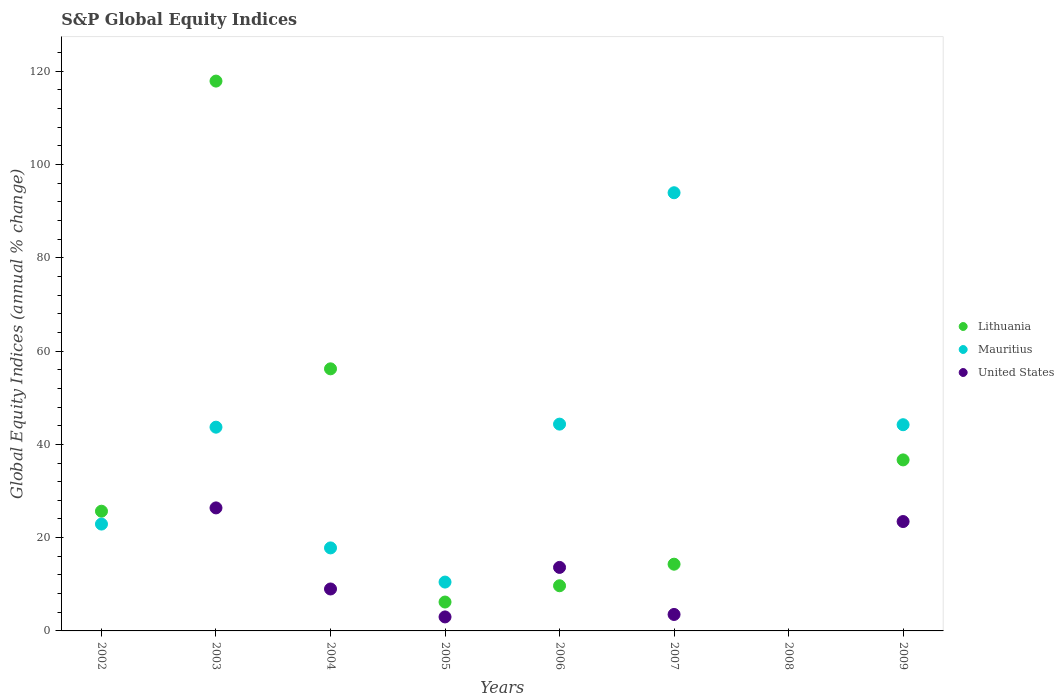Across all years, what is the maximum global equity indices in United States?
Keep it short and to the point. 26.38. In which year was the global equity indices in Mauritius maximum?
Ensure brevity in your answer.  2007. What is the total global equity indices in Mauritius in the graph?
Provide a short and direct response. 277.39. What is the difference between the global equity indices in Lithuania in 2006 and that in 2007?
Your response must be concise. -4.62. What is the difference between the global equity indices in Mauritius in 2002 and the global equity indices in Lithuania in 2005?
Provide a succinct answer. 16.72. What is the average global equity indices in United States per year?
Your answer should be very brief. 9.87. In the year 2009, what is the difference between the global equity indices in United States and global equity indices in Lithuania?
Your answer should be very brief. -13.22. What is the ratio of the global equity indices in Mauritius in 2003 to that in 2004?
Offer a terse response. 2.45. What is the difference between the highest and the second highest global equity indices in United States?
Provide a short and direct response. 2.93. What is the difference between the highest and the lowest global equity indices in Mauritius?
Provide a short and direct response. 93.96. Is the sum of the global equity indices in Lithuania in 2005 and 2007 greater than the maximum global equity indices in Mauritius across all years?
Your answer should be compact. No. Is the global equity indices in United States strictly greater than the global equity indices in Mauritius over the years?
Your answer should be very brief. No. Is the global equity indices in United States strictly less than the global equity indices in Lithuania over the years?
Ensure brevity in your answer.  No. How many years are there in the graph?
Your answer should be compact. 8. Does the graph contain any zero values?
Your answer should be very brief. Yes. Where does the legend appear in the graph?
Your answer should be compact. Center right. How many legend labels are there?
Give a very brief answer. 3. How are the legend labels stacked?
Give a very brief answer. Vertical. What is the title of the graph?
Your response must be concise. S&P Global Equity Indices. What is the label or title of the X-axis?
Keep it short and to the point. Years. What is the label or title of the Y-axis?
Provide a succinct answer. Global Equity Indices (annual % change). What is the Global Equity Indices (annual % change) of Lithuania in 2002?
Your answer should be very brief. 25.67. What is the Global Equity Indices (annual % change) in Mauritius in 2002?
Give a very brief answer. 22.91. What is the Global Equity Indices (annual % change) in United States in 2002?
Provide a succinct answer. 0. What is the Global Equity Indices (annual % change) of Lithuania in 2003?
Offer a very short reply. 117.9. What is the Global Equity Indices (annual % change) in Mauritius in 2003?
Ensure brevity in your answer.  43.69. What is the Global Equity Indices (annual % change) in United States in 2003?
Offer a terse response. 26.38. What is the Global Equity Indices (annual % change) of Lithuania in 2004?
Provide a succinct answer. 56.2. What is the Global Equity Indices (annual % change) of Mauritius in 2004?
Give a very brief answer. 17.8. What is the Global Equity Indices (annual % change) in United States in 2004?
Offer a terse response. 8.99. What is the Global Equity Indices (annual % change) of Lithuania in 2005?
Your answer should be compact. 6.19. What is the Global Equity Indices (annual % change) in Mauritius in 2005?
Provide a succinct answer. 10.47. What is the Global Equity Indices (annual % change) of United States in 2005?
Your response must be concise. 3. What is the Global Equity Indices (annual % change) of Lithuania in 2006?
Offer a terse response. 9.68. What is the Global Equity Indices (annual % change) of Mauritius in 2006?
Your answer should be very brief. 44.34. What is the Global Equity Indices (annual % change) in United States in 2006?
Your response must be concise. 13.62. What is the Global Equity Indices (annual % change) in Lithuania in 2007?
Offer a terse response. 14.31. What is the Global Equity Indices (annual % change) of Mauritius in 2007?
Make the answer very short. 93.96. What is the Global Equity Indices (annual % change) in United States in 2007?
Provide a succinct answer. 3.53. What is the Global Equity Indices (annual % change) in Lithuania in 2008?
Your answer should be compact. 0. What is the Global Equity Indices (annual % change) in Mauritius in 2008?
Provide a succinct answer. 0. What is the Global Equity Indices (annual % change) in United States in 2008?
Your answer should be very brief. 0. What is the Global Equity Indices (annual % change) in Lithuania in 2009?
Provide a succinct answer. 36.67. What is the Global Equity Indices (annual % change) in Mauritius in 2009?
Provide a short and direct response. 44.22. What is the Global Equity Indices (annual % change) of United States in 2009?
Offer a very short reply. 23.45. Across all years, what is the maximum Global Equity Indices (annual % change) of Lithuania?
Keep it short and to the point. 117.9. Across all years, what is the maximum Global Equity Indices (annual % change) of Mauritius?
Provide a succinct answer. 93.96. Across all years, what is the maximum Global Equity Indices (annual % change) of United States?
Your answer should be very brief. 26.38. Across all years, what is the minimum Global Equity Indices (annual % change) in Lithuania?
Your answer should be very brief. 0. What is the total Global Equity Indices (annual % change) in Lithuania in the graph?
Keep it short and to the point. 266.63. What is the total Global Equity Indices (annual % change) in Mauritius in the graph?
Your answer should be compact. 277.39. What is the total Global Equity Indices (annual % change) of United States in the graph?
Ensure brevity in your answer.  78.98. What is the difference between the Global Equity Indices (annual % change) in Lithuania in 2002 and that in 2003?
Provide a short and direct response. -92.23. What is the difference between the Global Equity Indices (annual % change) of Mauritius in 2002 and that in 2003?
Offer a terse response. -20.78. What is the difference between the Global Equity Indices (annual % change) of Lithuania in 2002 and that in 2004?
Make the answer very short. -30.53. What is the difference between the Global Equity Indices (annual % change) of Mauritius in 2002 and that in 2004?
Your answer should be compact. 5.11. What is the difference between the Global Equity Indices (annual % change) of Lithuania in 2002 and that in 2005?
Offer a terse response. 19.48. What is the difference between the Global Equity Indices (annual % change) of Mauritius in 2002 and that in 2005?
Keep it short and to the point. 12.44. What is the difference between the Global Equity Indices (annual % change) in Lithuania in 2002 and that in 2006?
Make the answer very short. 15.99. What is the difference between the Global Equity Indices (annual % change) in Mauritius in 2002 and that in 2006?
Ensure brevity in your answer.  -21.43. What is the difference between the Global Equity Indices (annual % change) in Lithuania in 2002 and that in 2007?
Your answer should be very brief. 11.36. What is the difference between the Global Equity Indices (annual % change) of Mauritius in 2002 and that in 2007?
Keep it short and to the point. -71.05. What is the difference between the Global Equity Indices (annual % change) of Lithuania in 2002 and that in 2009?
Make the answer very short. -11. What is the difference between the Global Equity Indices (annual % change) of Mauritius in 2002 and that in 2009?
Give a very brief answer. -21.31. What is the difference between the Global Equity Indices (annual % change) of Lithuania in 2003 and that in 2004?
Give a very brief answer. 61.7. What is the difference between the Global Equity Indices (annual % change) in Mauritius in 2003 and that in 2004?
Give a very brief answer. 25.89. What is the difference between the Global Equity Indices (annual % change) in United States in 2003 and that in 2004?
Make the answer very short. 17.39. What is the difference between the Global Equity Indices (annual % change) in Lithuania in 2003 and that in 2005?
Your answer should be compact. 111.71. What is the difference between the Global Equity Indices (annual % change) in Mauritius in 2003 and that in 2005?
Offer a very short reply. 33.22. What is the difference between the Global Equity Indices (annual % change) of United States in 2003 and that in 2005?
Ensure brevity in your answer.  23.38. What is the difference between the Global Equity Indices (annual % change) in Lithuania in 2003 and that in 2006?
Your response must be concise. 108.22. What is the difference between the Global Equity Indices (annual % change) of Mauritius in 2003 and that in 2006?
Offer a very short reply. -0.65. What is the difference between the Global Equity Indices (annual % change) in United States in 2003 and that in 2006?
Keep it short and to the point. 12.76. What is the difference between the Global Equity Indices (annual % change) of Lithuania in 2003 and that in 2007?
Your response must be concise. 103.59. What is the difference between the Global Equity Indices (annual % change) of Mauritius in 2003 and that in 2007?
Provide a succinct answer. -50.27. What is the difference between the Global Equity Indices (annual % change) in United States in 2003 and that in 2007?
Give a very brief answer. 22.85. What is the difference between the Global Equity Indices (annual % change) of Lithuania in 2003 and that in 2009?
Ensure brevity in your answer.  81.23. What is the difference between the Global Equity Indices (annual % change) of Mauritius in 2003 and that in 2009?
Make the answer very short. -0.53. What is the difference between the Global Equity Indices (annual % change) in United States in 2003 and that in 2009?
Give a very brief answer. 2.93. What is the difference between the Global Equity Indices (annual % change) in Lithuania in 2004 and that in 2005?
Keep it short and to the point. 50.01. What is the difference between the Global Equity Indices (annual % change) of Mauritius in 2004 and that in 2005?
Your answer should be compact. 7.33. What is the difference between the Global Equity Indices (annual % change) of United States in 2004 and that in 2005?
Provide a short and direct response. 5.99. What is the difference between the Global Equity Indices (annual % change) of Lithuania in 2004 and that in 2006?
Offer a terse response. 46.52. What is the difference between the Global Equity Indices (annual % change) in Mauritius in 2004 and that in 2006?
Ensure brevity in your answer.  -26.54. What is the difference between the Global Equity Indices (annual % change) of United States in 2004 and that in 2006?
Offer a terse response. -4.63. What is the difference between the Global Equity Indices (annual % change) of Lithuania in 2004 and that in 2007?
Provide a short and direct response. 41.89. What is the difference between the Global Equity Indices (annual % change) of Mauritius in 2004 and that in 2007?
Your response must be concise. -76.16. What is the difference between the Global Equity Indices (annual % change) of United States in 2004 and that in 2007?
Offer a terse response. 5.46. What is the difference between the Global Equity Indices (annual % change) of Lithuania in 2004 and that in 2009?
Provide a short and direct response. 19.53. What is the difference between the Global Equity Indices (annual % change) of Mauritius in 2004 and that in 2009?
Your answer should be very brief. -26.42. What is the difference between the Global Equity Indices (annual % change) of United States in 2004 and that in 2009?
Your answer should be compact. -14.46. What is the difference between the Global Equity Indices (annual % change) of Lithuania in 2005 and that in 2006?
Offer a very short reply. -3.49. What is the difference between the Global Equity Indices (annual % change) in Mauritius in 2005 and that in 2006?
Provide a succinct answer. -33.87. What is the difference between the Global Equity Indices (annual % change) in United States in 2005 and that in 2006?
Your answer should be compact. -10.62. What is the difference between the Global Equity Indices (annual % change) in Lithuania in 2005 and that in 2007?
Your answer should be compact. -8.11. What is the difference between the Global Equity Indices (annual % change) of Mauritius in 2005 and that in 2007?
Offer a very short reply. -83.48. What is the difference between the Global Equity Indices (annual % change) of United States in 2005 and that in 2007?
Provide a short and direct response. -0.53. What is the difference between the Global Equity Indices (annual % change) of Lithuania in 2005 and that in 2009?
Provide a succinct answer. -30.48. What is the difference between the Global Equity Indices (annual % change) in Mauritius in 2005 and that in 2009?
Ensure brevity in your answer.  -33.74. What is the difference between the Global Equity Indices (annual % change) in United States in 2005 and that in 2009?
Keep it short and to the point. -20.45. What is the difference between the Global Equity Indices (annual % change) of Lithuania in 2006 and that in 2007?
Give a very brief answer. -4.62. What is the difference between the Global Equity Indices (annual % change) of Mauritius in 2006 and that in 2007?
Your response must be concise. -49.62. What is the difference between the Global Equity Indices (annual % change) in United States in 2006 and that in 2007?
Provide a succinct answer. 10.09. What is the difference between the Global Equity Indices (annual % change) in Lithuania in 2006 and that in 2009?
Give a very brief answer. -26.99. What is the difference between the Global Equity Indices (annual % change) of Mauritius in 2006 and that in 2009?
Provide a short and direct response. 0.13. What is the difference between the Global Equity Indices (annual % change) in United States in 2006 and that in 2009?
Provide a succinct answer. -9.83. What is the difference between the Global Equity Indices (annual % change) in Lithuania in 2007 and that in 2009?
Provide a succinct answer. -22.36. What is the difference between the Global Equity Indices (annual % change) in Mauritius in 2007 and that in 2009?
Your answer should be very brief. 49.74. What is the difference between the Global Equity Indices (annual % change) in United States in 2007 and that in 2009?
Give a very brief answer. -19.92. What is the difference between the Global Equity Indices (annual % change) of Lithuania in 2002 and the Global Equity Indices (annual % change) of Mauritius in 2003?
Give a very brief answer. -18.02. What is the difference between the Global Equity Indices (annual % change) in Lithuania in 2002 and the Global Equity Indices (annual % change) in United States in 2003?
Offer a very short reply. -0.71. What is the difference between the Global Equity Indices (annual % change) in Mauritius in 2002 and the Global Equity Indices (annual % change) in United States in 2003?
Keep it short and to the point. -3.47. What is the difference between the Global Equity Indices (annual % change) of Lithuania in 2002 and the Global Equity Indices (annual % change) of Mauritius in 2004?
Your response must be concise. 7.87. What is the difference between the Global Equity Indices (annual % change) of Lithuania in 2002 and the Global Equity Indices (annual % change) of United States in 2004?
Your answer should be compact. 16.68. What is the difference between the Global Equity Indices (annual % change) in Mauritius in 2002 and the Global Equity Indices (annual % change) in United States in 2004?
Keep it short and to the point. 13.92. What is the difference between the Global Equity Indices (annual % change) in Lithuania in 2002 and the Global Equity Indices (annual % change) in Mauritius in 2005?
Offer a very short reply. 15.2. What is the difference between the Global Equity Indices (annual % change) in Lithuania in 2002 and the Global Equity Indices (annual % change) in United States in 2005?
Give a very brief answer. 22.67. What is the difference between the Global Equity Indices (annual % change) in Mauritius in 2002 and the Global Equity Indices (annual % change) in United States in 2005?
Provide a short and direct response. 19.91. What is the difference between the Global Equity Indices (annual % change) of Lithuania in 2002 and the Global Equity Indices (annual % change) of Mauritius in 2006?
Your response must be concise. -18.67. What is the difference between the Global Equity Indices (annual % change) of Lithuania in 2002 and the Global Equity Indices (annual % change) of United States in 2006?
Offer a terse response. 12.05. What is the difference between the Global Equity Indices (annual % change) of Mauritius in 2002 and the Global Equity Indices (annual % change) of United States in 2006?
Your answer should be compact. 9.29. What is the difference between the Global Equity Indices (annual % change) in Lithuania in 2002 and the Global Equity Indices (annual % change) in Mauritius in 2007?
Your response must be concise. -68.29. What is the difference between the Global Equity Indices (annual % change) of Lithuania in 2002 and the Global Equity Indices (annual % change) of United States in 2007?
Offer a terse response. 22.14. What is the difference between the Global Equity Indices (annual % change) in Mauritius in 2002 and the Global Equity Indices (annual % change) in United States in 2007?
Offer a very short reply. 19.38. What is the difference between the Global Equity Indices (annual % change) in Lithuania in 2002 and the Global Equity Indices (annual % change) in Mauritius in 2009?
Provide a succinct answer. -18.55. What is the difference between the Global Equity Indices (annual % change) of Lithuania in 2002 and the Global Equity Indices (annual % change) of United States in 2009?
Your response must be concise. 2.22. What is the difference between the Global Equity Indices (annual % change) of Mauritius in 2002 and the Global Equity Indices (annual % change) of United States in 2009?
Offer a terse response. -0.54. What is the difference between the Global Equity Indices (annual % change) of Lithuania in 2003 and the Global Equity Indices (annual % change) of Mauritius in 2004?
Keep it short and to the point. 100.1. What is the difference between the Global Equity Indices (annual % change) of Lithuania in 2003 and the Global Equity Indices (annual % change) of United States in 2004?
Offer a terse response. 108.91. What is the difference between the Global Equity Indices (annual % change) in Mauritius in 2003 and the Global Equity Indices (annual % change) in United States in 2004?
Offer a terse response. 34.7. What is the difference between the Global Equity Indices (annual % change) in Lithuania in 2003 and the Global Equity Indices (annual % change) in Mauritius in 2005?
Your response must be concise. 107.43. What is the difference between the Global Equity Indices (annual % change) in Lithuania in 2003 and the Global Equity Indices (annual % change) in United States in 2005?
Your answer should be very brief. 114.9. What is the difference between the Global Equity Indices (annual % change) of Mauritius in 2003 and the Global Equity Indices (annual % change) of United States in 2005?
Make the answer very short. 40.69. What is the difference between the Global Equity Indices (annual % change) of Lithuania in 2003 and the Global Equity Indices (annual % change) of Mauritius in 2006?
Give a very brief answer. 73.56. What is the difference between the Global Equity Indices (annual % change) in Lithuania in 2003 and the Global Equity Indices (annual % change) in United States in 2006?
Provide a short and direct response. 104.28. What is the difference between the Global Equity Indices (annual % change) of Mauritius in 2003 and the Global Equity Indices (annual % change) of United States in 2006?
Offer a terse response. 30.07. What is the difference between the Global Equity Indices (annual % change) in Lithuania in 2003 and the Global Equity Indices (annual % change) in Mauritius in 2007?
Your answer should be very brief. 23.94. What is the difference between the Global Equity Indices (annual % change) of Lithuania in 2003 and the Global Equity Indices (annual % change) of United States in 2007?
Give a very brief answer. 114.37. What is the difference between the Global Equity Indices (annual % change) of Mauritius in 2003 and the Global Equity Indices (annual % change) of United States in 2007?
Provide a succinct answer. 40.16. What is the difference between the Global Equity Indices (annual % change) in Lithuania in 2003 and the Global Equity Indices (annual % change) in Mauritius in 2009?
Your answer should be very brief. 73.68. What is the difference between the Global Equity Indices (annual % change) of Lithuania in 2003 and the Global Equity Indices (annual % change) of United States in 2009?
Provide a short and direct response. 94.45. What is the difference between the Global Equity Indices (annual % change) in Mauritius in 2003 and the Global Equity Indices (annual % change) in United States in 2009?
Make the answer very short. 20.24. What is the difference between the Global Equity Indices (annual % change) of Lithuania in 2004 and the Global Equity Indices (annual % change) of Mauritius in 2005?
Provide a short and direct response. 45.73. What is the difference between the Global Equity Indices (annual % change) of Lithuania in 2004 and the Global Equity Indices (annual % change) of United States in 2005?
Your answer should be very brief. 53.2. What is the difference between the Global Equity Indices (annual % change) in Mauritius in 2004 and the Global Equity Indices (annual % change) in United States in 2005?
Your response must be concise. 14.8. What is the difference between the Global Equity Indices (annual % change) of Lithuania in 2004 and the Global Equity Indices (annual % change) of Mauritius in 2006?
Keep it short and to the point. 11.86. What is the difference between the Global Equity Indices (annual % change) of Lithuania in 2004 and the Global Equity Indices (annual % change) of United States in 2006?
Give a very brief answer. 42.58. What is the difference between the Global Equity Indices (annual % change) of Mauritius in 2004 and the Global Equity Indices (annual % change) of United States in 2006?
Keep it short and to the point. 4.18. What is the difference between the Global Equity Indices (annual % change) of Lithuania in 2004 and the Global Equity Indices (annual % change) of Mauritius in 2007?
Your answer should be very brief. -37.76. What is the difference between the Global Equity Indices (annual % change) in Lithuania in 2004 and the Global Equity Indices (annual % change) in United States in 2007?
Ensure brevity in your answer.  52.67. What is the difference between the Global Equity Indices (annual % change) in Mauritius in 2004 and the Global Equity Indices (annual % change) in United States in 2007?
Provide a short and direct response. 14.27. What is the difference between the Global Equity Indices (annual % change) in Lithuania in 2004 and the Global Equity Indices (annual % change) in Mauritius in 2009?
Offer a very short reply. 11.98. What is the difference between the Global Equity Indices (annual % change) of Lithuania in 2004 and the Global Equity Indices (annual % change) of United States in 2009?
Your answer should be very brief. 32.75. What is the difference between the Global Equity Indices (annual % change) in Mauritius in 2004 and the Global Equity Indices (annual % change) in United States in 2009?
Make the answer very short. -5.65. What is the difference between the Global Equity Indices (annual % change) in Lithuania in 2005 and the Global Equity Indices (annual % change) in Mauritius in 2006?
Provide a short and direct response. -38.15. What is the difference between the Global Equity Indices (annual % change) in Lithuania in 2005 and the Global Equity Indices (annual % change) in United States in 2006?
Keep it short and to the point. -7.42. What is the difference between the Global Equity Indices (annual % change) of Mauritius in 2005 and the Global Equity Indices (annual % change) of United States in 2006?
Give a very brief answer. -3.14. What is the difference between the Global Equity Indices (annual % change) in Lithuania in 2005 and the Global Equity Indices (annual % change) in Mauritius in 2007?
Provide a short and direct response. -87.77. What is the difference between the Global Equity Indices (annual % change) in Lithuania in 2005 and the Global Equity Indices (annual % change) in United States in 2007?
Offer a very short reply. 2.67. What is the difference between the Global Equity Indices (annual % change) of Mauritius in 2005 and the Global Equity Indices (annual % change) of United States in 2007?
Provide a succinct answer. 6.95. What is the difference between the Global Equity Indices (annual % change) of Lithuania in 2005 and the Global Equity Indices (annual % change) of Mauritius in 2009?
Offer a terse response. -38.02. What is the difference between the Global Equity Indices (annual % change) of Lithuania in 2005 and the Global Equity Indices (annual % change) of United States in 2009?
Your response must be concise. -17.26. What is the difference between the Global Equity Indices (annual % change) in Mauritius in 2005 and the Global Equity Indices (annual % change) in United States in 2009?
Provide a short and direct response. -12.98. What is the difference between the Global Equity Indices (annual % change) of Lithuania in 2006 and the Global Equity Indices (annual % change) of Mauritius in 2007?
Your answer should be very brief. -84.28. What is the difference between the Global Equity Indices (annual % change) of Lithuania in 2006 and the Global Equity Indices (annual % change) of United States in 2007?
Provide a succinct answer. 6.15. What is the difference between the Global Equity Indices (annual % change) of Mauritius in 2006 and the Global Equity Indices (annual % change) of United States in 2007?
Your answer should be compact. 40.81. What is the difference between the Global Equity Indices (annual % change) of Lithuania in 2006 and the Global Equity Indices (annual % change) of Mauritius in 2009?
Offer a terse response. -34.53. What is the difference between the Global Equity Indices (annual % change) of Lithuania in 2006 and the Global Equity Indices (annual % change) of United States in 2009?
Your answer should be compact. -13.77. What is the difference between the Global Equity Indices (annual % change) of Mauritius in 2006 and the Global Equity Indices (annual % change) of United States in 2009?
Make the answer very short. 20.89. What is the difference between the Global Equity Indices (annual % change) in Lithuania in 2007 and the Global Equity Indices (annual % change) in Mauritius in 2009?
Give a very brief answer. -29.91. What is the difference between the Global Equity Indices (annual % change) of Lithuania in 2007 and the Global Equity Indices (annual % change) of United States in 2009?
Give a very brief answer. -9.15. What is the difference between the Global Equity Indices (annual % change) in Mauritius in 2007 and the Global Equity Indices (annual % change) in United States in 2009?
Give a very brief answer. 70.51. What is the average Global Equity Indices (annual % change) of Lithuania per year?
Make the answer very short. 33.33. What is the average Global Equity Indices (annual % change) in Mauritius per year?
Your response must be concise. 34.67. What is the average Global Equity Indices (annual % change) in United States per year?
Make the answer very short. 9.87. In the year 2002, what is the difference between the Global Equity Indices (annual % change) of Lithuania and Global Equity Indices (annual % change) of Mauritius?
Your answer should be compact. 2.76. In the year 2003, what is the difference between the Global Equity Indices (annual % change) in Lithuania and Global Equity Indices (annual % change) in Mauritius?
Provide a short and direct response. 74.21. In the year 2003, what is the difference between the Global Equity Indices (annual % change) in Lithuania and Global Equity Indices (annual % change) in United States?
Offer a very short reply. 91.52. In the year 2003, what is the difference between the Global Equity Indices (annual % change) of Mauritius and Global Equity Indices (annual % change) of United States?
Keep it short and to the point. 17.31. In the year 2004, what is the difference between the Global Equity Indices (annual % change) of Lithuania and Global Equity Indices (annual % change) of Mauritius?
Provide a short and direct response. 38.4. In the year 2004, what is the difference between the Global Equity Indices (annual % change) in Lithuania and Global Equity Indices (annual % change) in United States?
Offer a very short reply. 47.21. In the year 2004, what is the difference between the Global Equity Indices (annual % change) in Mauritius and Global Equity Indices (annual % change) in United States?
Offer a terse response. 8.81. In the year 2005, what is the difference between the Global Equity Indices (annual % change) in Lithuania and Global Equity Indices (annual % change) in Mauritius?
Offer a terse response. -4.28. In the year 2005, what is the difference between the Global Equity Indices (annual % change) in Lithuania and Global Equity Indices (annual % change) in United States?
Make the answer very short. 3.19. In the year 2005, what is the difference between the Global Equity Indices (annual % change) of Mauritius and Global Equity Indices (annual % change) of United States?
Provide a short and direct response. 7.47. In the year 2006, what is the difference between the Global Equity Indices (annual % change) of Lithuania and Global Equity Indices (annual % change) of Mauritius?
Your answer should be very brief. -34.66. In the year 2006, what is the difference between the Global Equity Indices (annual % change) in Lithuania and Global Equity Indices (annual % change) in United States?
Your response must be concise. -3.94. In the year 2006, what is the difference between the Global Equity Indices (annual % change) of Mauritius and Global Equity Indices (annual % change) of United States?
Offer a terse response. 30.72. In the year 2007, what is the difference between the Global Equity Indices (annual % change) in Lithuania and Global Equity Indices (annual % change) in Mauritius?
Make the answer very short. -79.65. In the year 2007, what is the difference between the Global Equity Indices (annual % change) of Lithuania and Global Equity Indices (annual % change) of United States?
Make the answer very short. 10.78. In the year 2007, what is the difference between the Global Equity Indices (annual % change) of Mauritius and Global Equity Indices (annual % change) of United States?
Ensure brevity in your answer.  90.43. In the year 2009, what is the difference between the Global Equity Indices (annual % change) of Lithuania and Global Equity Indices (annual % change) of Mauritius?
Offer a terse response. -7.55. In the year 2009, what is the difference between the Global Equity Indices (annual % change) of Lithuania and Global Equity Indices (annual % change) of United States?
Ensure brevity in your answer.  13.22. In the year 2009, what is the difference between the Global Equity Indices (annual % change) of Mauritius and Global Equity Indices (annual % change) of United States?
Provide a succinct answer. 20.76. What is the ratio of the Global Equity Indices (annual % change) in Lithuania in 2002 to that in 2003?
Make the answer very short. 0.22. What is the ratio of the Global Equity Indices (annual % change) of Mauritius in 2002 to that in 2003?
Ensure brevity in your answer.  0.52. What is the ratio of the Global Equity Indices (annual % change) in Lithuania in 2002 to that in 2004?
Your response must be concise. 0.46. What is the ratio of the Global Equity Indices (annual % change) of Mauritius in 2002 to that in 2004?
Provide a short and direct response. 1.29. What is the ratio of the Global Equity Indices (annual % change) of Lithuania in 2002 to that in 2005?
Give a very brief answer. 4.14. What is the ratio of the Global Equity Indices (annual % change) of Mauritius in 2002 to that in 2005?
Offer a very short reply. 2.19. What is the ratio of the Global Equity Indices (annual % change) in Lithuania in 2002 to that in 2006?
Make the answer very short. 2.65. What is the ratio of the Global Equity Indices (annual % change) of Mauritius in 2002 to that in 2006?
Your answer should be very brief. 0.52. What is the ratio of the Global Equity Indices (annual % change) in Lithuania in 2002 to that in 2007?
Offer a terse response. 1.79. What is the ratio of the Global Equity Indices (annual % change) of Mauritius in 2002 to that in 2007?
Offer a terse response. 0.24. What is the ratio of the Global Equity Indices (annual % change) in Lithuania in 2002 to that in 2009?
Provide a succinct answer. 0.7. What is the ratio of the Global Equity Indices (annual % change) of Mauritius in 2002 to that in 2009?
Provide a succinct answer. 0.52. What is the ratio of the Global Equity Indices (annual % change) of Lithuania in 2003 to that in 2004?
Provide a succinct answer. 2.1. What is the ratio of the Global Equity Indices (annual % change) of Mauritius in 2003 to that in 2004?
Ensure brevity in your answer.  2.45. What is the ratio of the Global Equity Indices (annual % change) of United States in 2003 to that in 2004?
Give a very brief answer. 2.93. What is the ratio of the Global Equity Indices (annual % change) of Lithuania in 2003 to that in 2005?
Provide a succinct answer. 19.03. What is the ratio of the Global Equity Indices (annual % change) in Mauritius in 2003 to that in 2005?
Ensure brevity in your answer.  4.17. What is the ratio of the Global Equity Indices (annual % change) in United States in 2003 to that in 2005?
Provide a short and direct response. 8.79. What is the ratio of the Global Equity Indices (annual % change) in Lithuania in 2003 to that in 2006?
Offer a very short reply. 12.18. What is the ratio of the Global Equity Indices (annual % change) in Mauritius in 2003 to that in 2006?
Keep it short and to the point. 0.99. What is the ratio of the Global Equity Indices (annual % change) in United States in 2003 to that in 2006?
Your answer should be compact. 1.94. What is the ratio of the Global Equity Indices (annual % change) of Lithuania in 2003 to that in 2007?
Your answer should be very brief. 8.24. What is the ratio of the Global Equity Indices (annual % change) in Mauritius in 2003 to that in 2007?
Your response must be concise. 0.47. What is the ratio of the Global Equity Indices (annual % change) of United States in 2003 to that in 2007?
Offer a very short reply. 7.47. What is the ratio of the Global Equity Indices (annual % change) of Lithuania in 2003 to that in 2009?
Offer a very short reply. 3.22. What is the ratio of the Global Equity Indices (annual % change) of United States in 2003 to that in 2009?
Keep it short and to the point. 1.12. What is the ratio of the Global Equity Indices (annual % change) in Lithuania in 2004 to that in 2005?
Your response must be concise. 9.07. What is the ratio of the Global Equity Indices (annual % change) in Mauritius in 2004 to that in 2005?
Offer a very short reply. 1.7. What is the ratio of the Global Equity Indices (annual % change) of United States in 2004 to that in 2005?
Provide a short and direct response. 3. What is the ratio of the Global Equity Indices (annual % change) of Lithuania in 2004 to that in 2006?
Offer a very short reply. 5.8. What is the ratio of the Global Equity Indices (annual % change) of Mauritius in 2004 to that in 2006?
Ensure brevity in your answer.  0.4. What is the ratio of the Global Equity Indices (annual % change) in United States in 2004 to that in 2006?
Provide a succinct answer. 0.66. What is the ratio of the Global Equity Indices (annual % change) in Lithuania in 2004 to that in 2007?
Your answer should be very brief. 3.93. What is the ratio of the Global Equity Indices (annual % change) in Mauritius in 2004 to that in 2007?
Your answer should be very brief. 0.19. What is the ratio of the Global Equity Indices (annual % change) in United States in 2004 to that in 2007?
Your answer should be very brief. 2.55. What is the ratio of the Global Equity Indices (annual % change) in Lithuania in 2004 to that in 2009?
Give a very brief answer. 1.53. What is the ratio of the Global Equity Indices (annual % change) in Mauritius in 2004 to that in 2009?
Ensure brevity in your answer.  0.4. What is the ratio of the Global Equity Indices (annual % change) of United States in 2004 to that in 2009?
Make the answer very short. 0.38. What is the ratio of the Global Equity Indices (annual % change) in Lithuania in 2005 to that in 2006?
Offer a terse response. 0.64. What is the ratio of the Global Equity Indices (annual % change) in Mauritius in 2005 to that in 2006?
Ensure brevity in your answer.  0.24. What is the ratio of the Global Equity Indices (annual % change) in United States in 2005 to that in 2006?
Give a very brief answer. 0.22. What is the ratio of the Global Equity Indices (annual % change) of Lithuania in 2005 to that in 2007?
Provide a succinct answer. 0.43. What is the ratio of the Global Equity Indices (annual % change) in Mauritius in 2005 to that in 2007?
Your answer should be compact. 0.11. What is the ratio of the Global Equity Indices (annual % change) in United States in 2005 to that in 2007?
Keep it short and to the point. 0.85. What is the ratio of the Global Equity Indices (annual % change) of Lithuania in 2005 to that in 2009?
Provide a succinct answer. 0.17. What is the ratio of the Global Equity Indices (annual % change) in Mauritius in 2005 to that in 2009?
Your response must be concise. 0.24. What is the ratio of the Global Equity Indices (annual % change) of United States in 2005 to that in 2009?
Your response must be concise. 0.13. What is the ratio of the Global Equity Indices (annual % change) of Lithuania in 2006 to that in 2007?
Your answer should be very brief. 0.68. What is the ratio of the Global Equity Indices (annual % change) in Mauritius in 2006 to that in 2007?
Keep it short and to the point. 0.47. What is the ratio of the Global Equity Indices (annual % change) in United States in 2006 to that in 2007?
Provide a short and direct response. 3.86. What is the ratio of the Global Equity Indices (annual % change) in Lithuania in 2006 to that in 2009?
Offer a very short reply. 0.26. What is the ratio of the Global Equity Indices (annual % change) in Mauritius in 2006 to that in 2009?
Offer a terse response. 1. What is the ratio of the Global Equity Indices (annual % change) of United States in 2006 to that in 2009?
Ensure brevity in your answer.  0.58. What is the ratio of the Global Equity Indices (annual % change) of Lithuania in 2007 to that in 2009?
Your response must be concise. 0.39. What is the ratio of the Global Equity Indices (annual % change) of Mauritius in 2007 to that in 2009?
Offer a very short reply. 2.12. What is the ratio of the Global Equity Indices (annual % change) of United States in 2007 to that in 2009?
Offer a very short reply. 0.15. What is the difference between the highest and the second highest Global Equity Indices (annual % change) in Lithuania?
Offer a terse response. 61.7. What is the difference between the highest and the second highest Global Equity Indices (annual % change) of Mauritius?
Ensure brevity in your answer.  49.62. What is the difference between the highest and the second highest Global Equity Indices (annual % change) of United States?
Your answer should be very brief. 2.93. What is the difference between the highest and the lowest Global Equity Indices (annual % change) in Lithuania?
Offer a terse response. 117.9. What is the difference between the highest and the lowest Global Equity Indices (annual % change) of Mauritius?
Your answer should be compact. 93.96. What is the difference between the highest and the lowest Global Equity Indices (annual % change) of United States?
Give a very brief answer. 26.38. 